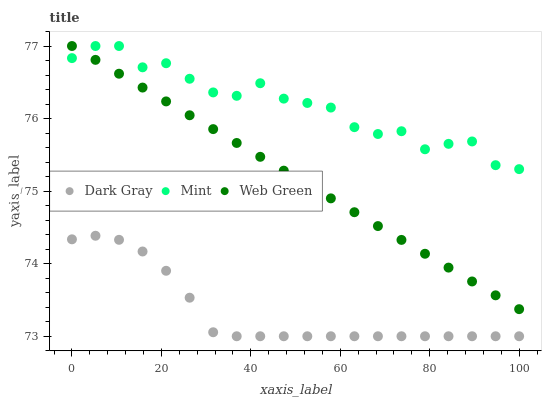Does Dark Gray have the minimum area under the curve?
Answer yes or no. Yes. Does Mint have the maximum area under the curve?
Answer yes or no. Yes. Does Web Green have the minimum area under the curve?
Answer yes or no. No. Does Web Green have the maximum area under the curve?
Answer yes or no. No. Is Web Green the smoothest?
Answer yes or no. Yes. Is Mint the roughest?
Answer yes or no. Yes. Is Mint the smoothest?
Answer yes or no. No. Is Web Green the roughest?
Answer yes or no. No. Does Dark Gray have the lowest value?
Answer yes or no. Yes. Does Web Green have the lowest value?
Answer yes or no. No. Does Web Green have the highest value?
Answer yes or no. Yes. Is Dark Gray less than Web Green?
Answer yes or no. Yes. Is Web Green greater than Dark Gray?
Answer yes or no. Yes. Does Mint intersect Web Green?
Answer yes or no. Yes. Is Mint less than Web Green?
Answer yes or no. No. Is Mint greater than Web Green?
Answer yes or no. No. Does Dark Gray intersect Web Green?
Answer yes or no. No. 